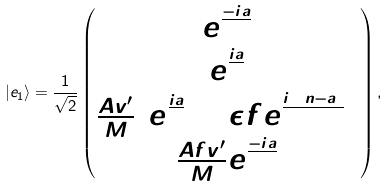<formula> <loc_0><loc_0><loc_500><loc_500>| e _ { 1 } \rangle = \frac { 1 } { \sqrt { 2 } } \begin{pmatrix} e ^ { \frac { - i a } { 2 } } \\ e ^ { \frac { i a } { 2 } } \\ \frac { A v ^ { \prime } } { M } ( e ^ { \frac { i a } { 2 } } + \epsilon f e ^ { \frac { i ( 2 n - a ) } { 2 } } ) \\ \frac { A f v ^ { \prime } } { M } e ^ { \frac { - i a } { 2 } } \end{pmatrix} ,</formula> 